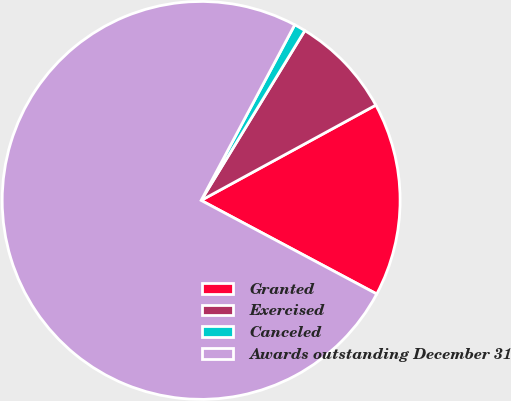Convert chart to OTSL. <chart><loc_0><loc_0><loc_500><loc_500><pie_chart><fcel>Granted<fcel>Exercised<fcel>Canceled<fcel>Awards outstanding December 31<nl><fcel>15.74%<fcel>8.33%<fcel>0.93%<fcel>75.0%<nl></chart> 